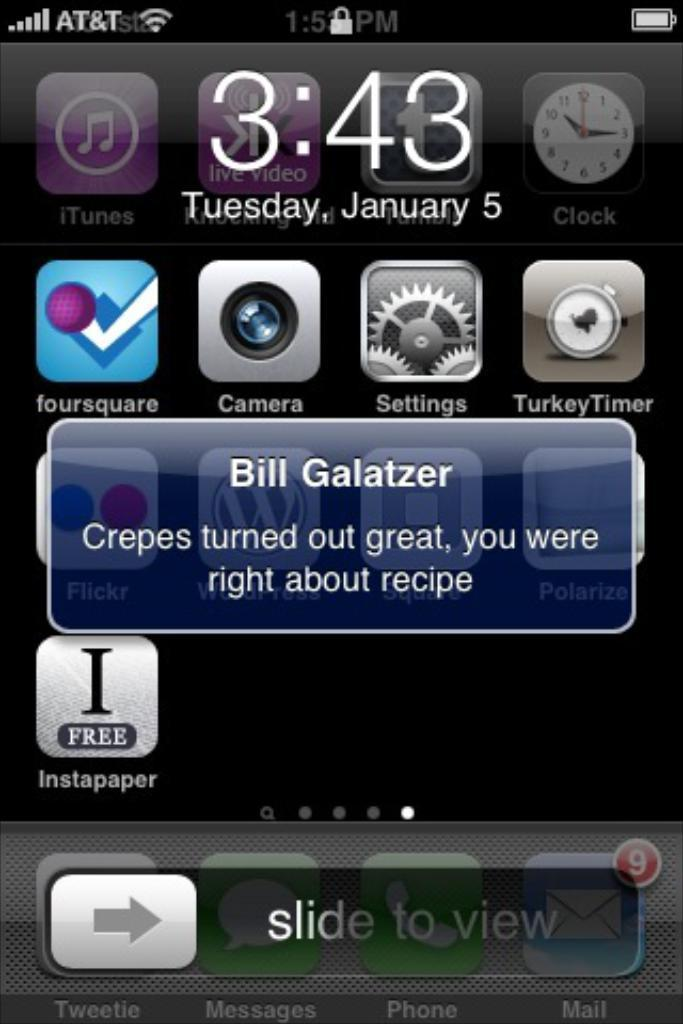Provide a one-sentence caption for the provided image. A text message from Bill Galatzer is displayed on a cell phone screen. 